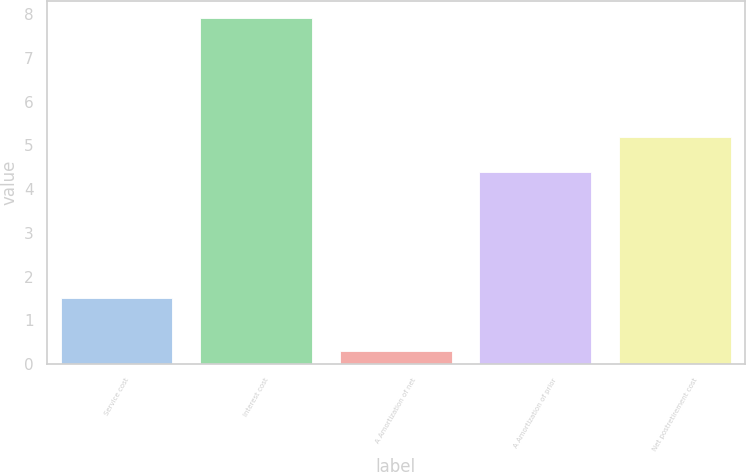<chart> <loc_0><loc_0><loc_500><loc_500><bar_chart><fcel>Service cost<fcel>Interest cost<fcel>A Amortization of net<fcel>A Amortization of prior<fcel>Net postretirement cost<nl><fcel>1.5<fcel>7.9<fcel>0.3<fcel>4.4<fcel>5.2<nl></chart> 